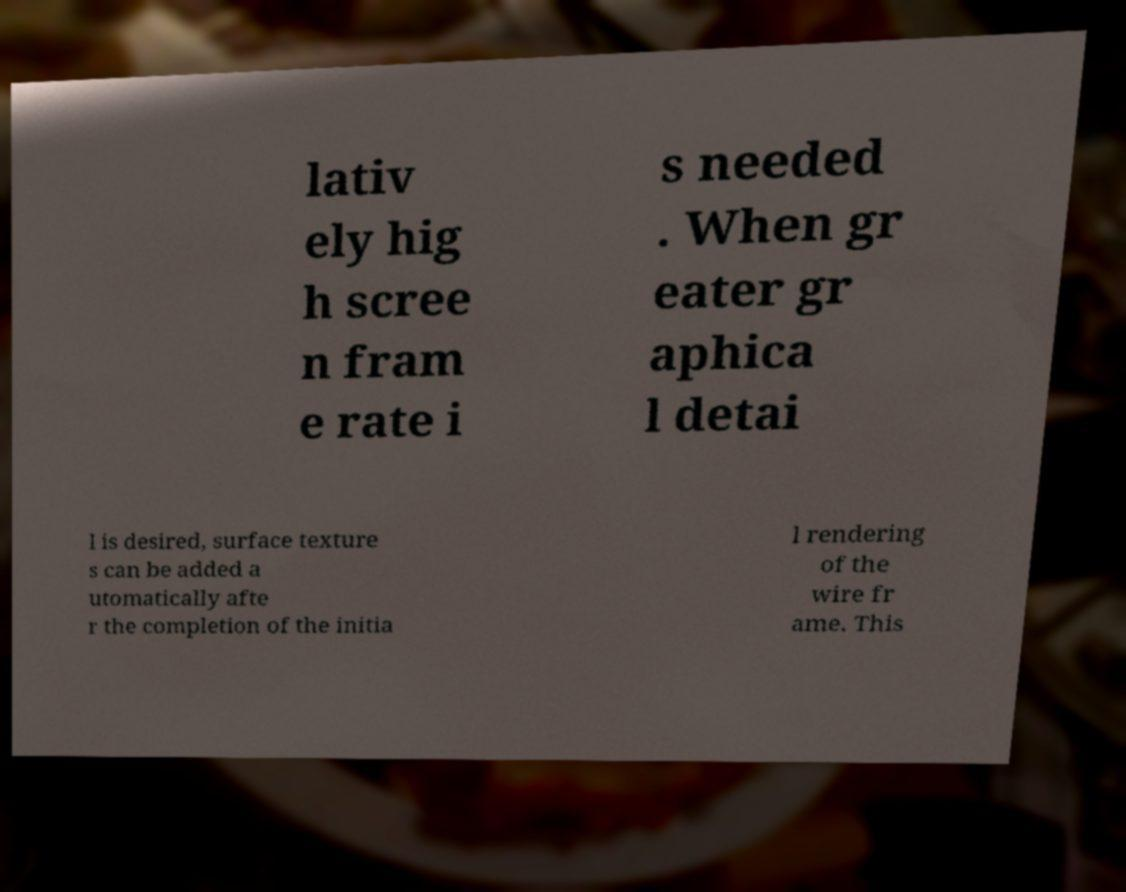There's text embedded in this image that I need extracted. Can you transcribe it verbatim? lativ ely hig h scree n fram e rate i s needed . When gr eater gr aphica l detai l is desired, surface texture s can be added a utomatically afte r the completion of the initia l rendering of the wire fr ame. This 